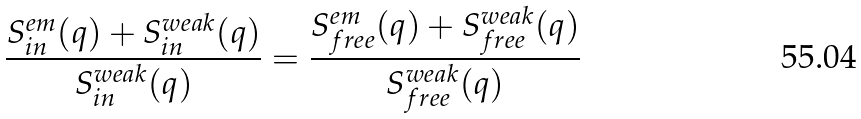<formula> <loc_0><loc_0><loc_500><loc_500>\frac { S ^ { e m } _ { i n } ( q ) + S ^ { w e a k } _ { i n } ( q ) } { S ^ { w e a k } _ { i n } ( q ) } = \frac { S ^ { e m } _ { f r e e } ( q ) + S ^ { w e a k } _ { f r e e } ( q ) } { S ^ { w e a k } _ { f r e e } ( q ) }</formula> 